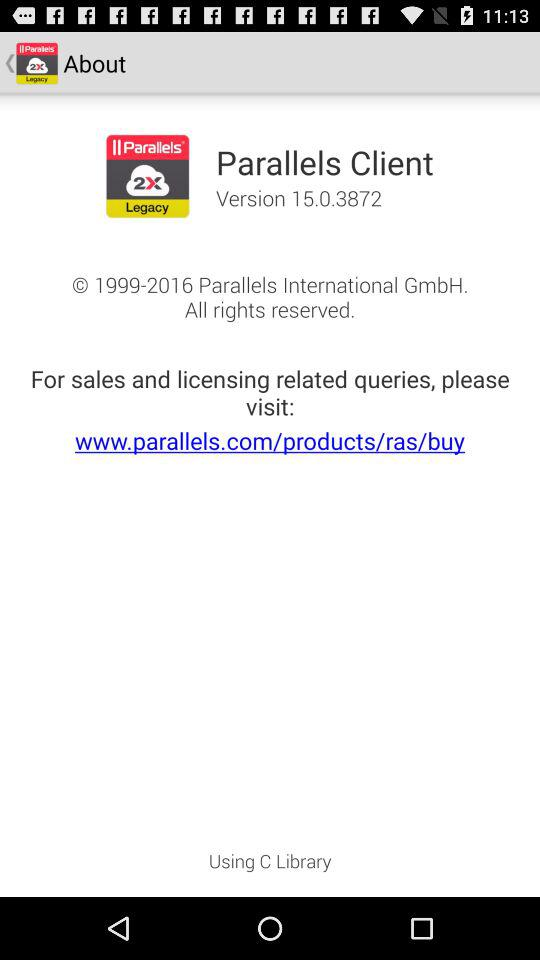What is the app name? The app name is "Parallels Client". 